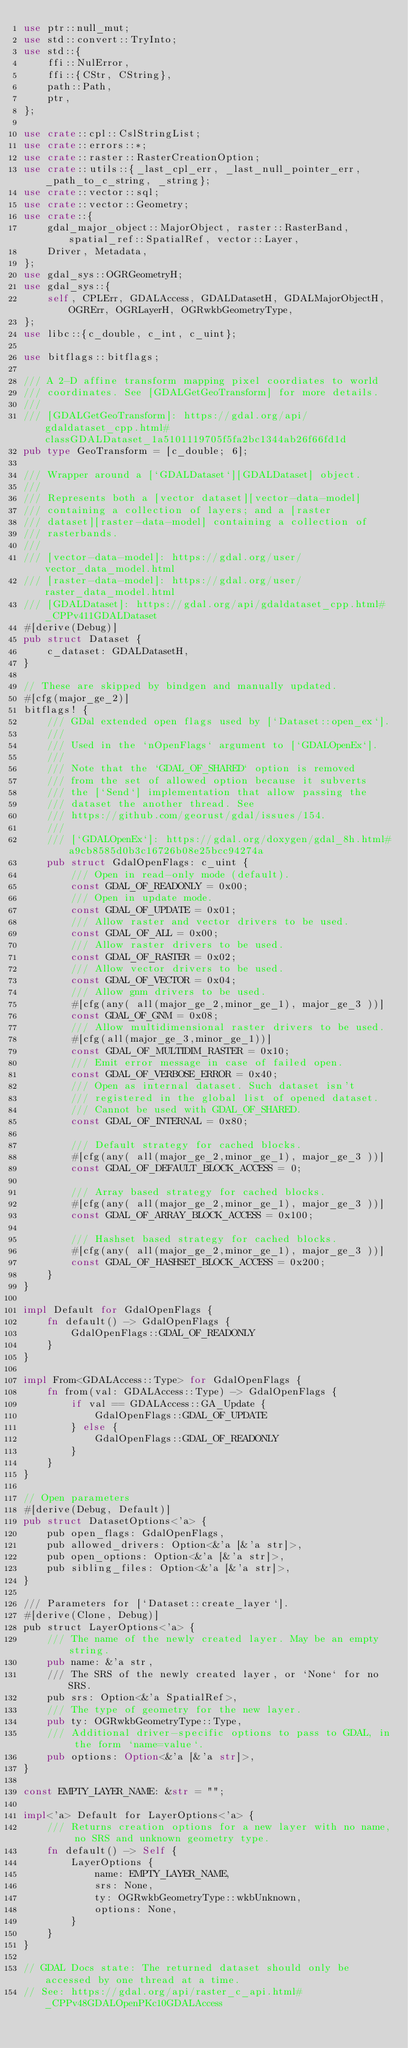<code> <loc_0><loc_0><loc_500><loc_500><_Rust_>use ptr::null_mut;
use std::convert::TryInto;
use std::{
    ffi::NulError,
    ffi::{CStr, CString},
    path::Path,
    ptr,
};

use crate::cpl::CslStringList;
use crate::errors::*;
use crate::raster::RasterCreationOption;
use crate::utils::{_last_cpl_err, _last_null_pointer_err, _path_to_c_string, _string};
use crate::vector::sql;
use crate::vector::Geometry;
use crate::{
    gdal_major_object::MajorObject, raster::RasterBand, spatial_ref::SpatialRef, vector::Layer,
    Driver, Metadata,
};
use gdal_sys::OGRGeometryH;
use gdal_sys::{
    self, CPLErr, GDALAccess, GDALDatasetH, GDALMajorObjectH, OGRErr, OGRLayerH, OGRwkbGeometryType,
};
use libc::{c_double, c_int, c_uint};

use bitflags::bitflags;

/// A 2-D affine transform mapping pixel coordiates to world
/// coordinates. See [GDALGetGeoTransform] for more details.
///
/// [GDALGetGeoTransform]: https://gdal.org/api/gdaldataset_cpp.html#classGDALDataset_1a5101119705f5fa2bc1344ab26f66fd1d
pub type GeoTransform = [c_double; 6];

/// Wrapper around a [`GDALDataset`][GDALDataset] object.
///
/// Represents both a [vector dataset][vector-data-model]
/// containing a collection of layers; and a [raster
/// dataset][raster-data-model] containing a collection of
/// rasterbands.
///
/// [vector-data-model]: https://gdal.org/user/vector_data_model.html
/// [raster-data-model]: https://gdal.org/user/raster_data_model.html
/// [GDALDataset]: https://gdal.org/api/gdaldataset_cpp.html#_CPPv411GDALDataset
#[derive(Debug)]
pub struct Dataset {
    c_dataset: GDALDatasetH,
}

// These are skipped by bindgen and manually updated.
#[cfg(major_ge_2)]
bitflags! {
    /// GDal extended open flags used by [`Dataset::open_ex`].
    ///
    /// Used in the `nOpenFlags` argument to [`GDALOpenEx`].
    ///
    /// Note that the `GDAL_OF_SHARED` option is removed
    /// from the set of allowed option because it subverts
    /// the [`Send`] implementation that allow passing the
    /// dataset the another thread. See
    /// https://github.com/georust/gdal/issues/154.
    ///
    /// [`GDALOpenEx`]: https://gdal.org/doxygen/gdal_8h.html#a9cb8585d0b3c16726b08e25bcc94274a
    pub struct GdalOpenFlags: c_uint {
        /// Open in read-only mode (default).
        const GDAL_OF_READONLY = 0x00;
        /// Open in update mode.
        const GDAL_OF_UPDATE = 0x01;
        /// Allow raster and vector drivers to be used.
        const GDAL_OF_ALL = 0x00;
        /// Allow raster drivers to be used.
        const GDAL_OF_RASTER = 0x02;
        /// Allow vector drivers to be used.
        const GDAL_OF_VECTOR = 0x04;
        /// Allow gnm drivers to be used.
        #[cfg(any( all(major_ge_2,minor_ge_1), major_ge_3 ))]
        const GDAL_OF_GNM = 0x08;
        /// Allow multidimensional raster drivers to be used.
        #[cfg(all(major_ge_3,minor_ge_1))]
        const GDAL_OF_MULTIDIM_RASTER = 0x10;
        /// Emit error message in case of failed open.
        const GDAL_OF_VERBOSE_ERROR = 0x40;
        /// Open as internal dataset. Such dataset isn't
        /// registered in the global list of opened dataset.
        /// Cannot be used with GDAL_OF_SHARED.
        const GDAL_OF_INTERNAL = 0x80;

        /// Default strategy for cached blocks.
        #[cfg(any( all(major_ge_2,minor_ge_1), major_ge_3 ))]
        const GDAL_OF_DEFAULT_BLOCK_ACCESS = 0;

        /// Array based strategy for cached blocks.
        #[cfg(any( all(major_ge_2,minor_ge_1), major_ge_3 ))]
        const GDAL_OF_ARRAY_BLOCK_ACCESS = 0x100;

        /// Hashset based strategy for cached blocks.
        #[cfg(any( all(major_ge_2,minor_ge_1), major_ge_3 ))]
        const GDAL_OF_HASHSET_BLOCK_ACCESS = 0x200;
    }
}

impl Default for GdalOpenFlags {
    fn default() -> GdalOpenFlags {
        GdalOpenFlags::GDAL_OF_READONLY
    }
}

impl From<GDALAccess::Type> for GdalOpenFlags {
    fn from(val: GDALAccess::Type) -> GdalOpenFlags {
        if val == GDALAccess::GA_Update {
            GdalOpenFlags::GDAL_OF_UPDATE
        } else {
            GdalOpenFlags::GDAL_OF_READONLY
        }
    }
}

// Open parameters
#[derive(Debug, Default)]
pub struct DatasetOptions<'a> {
    pub open_flags: GdalOpenFlags,
    pub allowed_drivers: Option<&'a [&'a str]>,
    pub open_options: Option<&'a [&'a str]>,
    pub sibling_files: Option<&'a [&'a str]>,
}

/// Parameters for [`Dataset::create_layer`].
#[derive(Clone, Debug)]
pub struct LayerOptions<'a> {
    /// The name of the newly created layer. May be an empty string.
    pub name: &'a str,
    /// The SRS of the newly created layer, or `None` for no SRS.
    pub srs: Option<&'a SpatialRef>,
    /// The type of geometry for the new layer.
    pub ty: OGRwkbGeometryType::Type,
    /// Additional driver-specific options to pass to GDAL, in the form `name=value`.
    pub options: Option<&'a [&'a str]>,
}

const EMPTY_LAYER_NAME: &str = "";

impl<'a> Default for LayerOptions<'a> {
    /// Returns creation options for a new layer with no name, no SRS and unknown geometry type.
    fn default() -> Self {
        LayerOptions {
            name: EMPTY_LAYER_NAME,
            srs: None,
            ty: OGRwkbGeometryType::wkbUnknown,
            options: None,
        }
    }
}

// GDAL Docs state: The returned dataset should only be accessed by one thread at a time.
// See: https://gdal.org/api/raster_c_api.html#_CPPv48GDALOpenPKc10GDALAccess</code> 